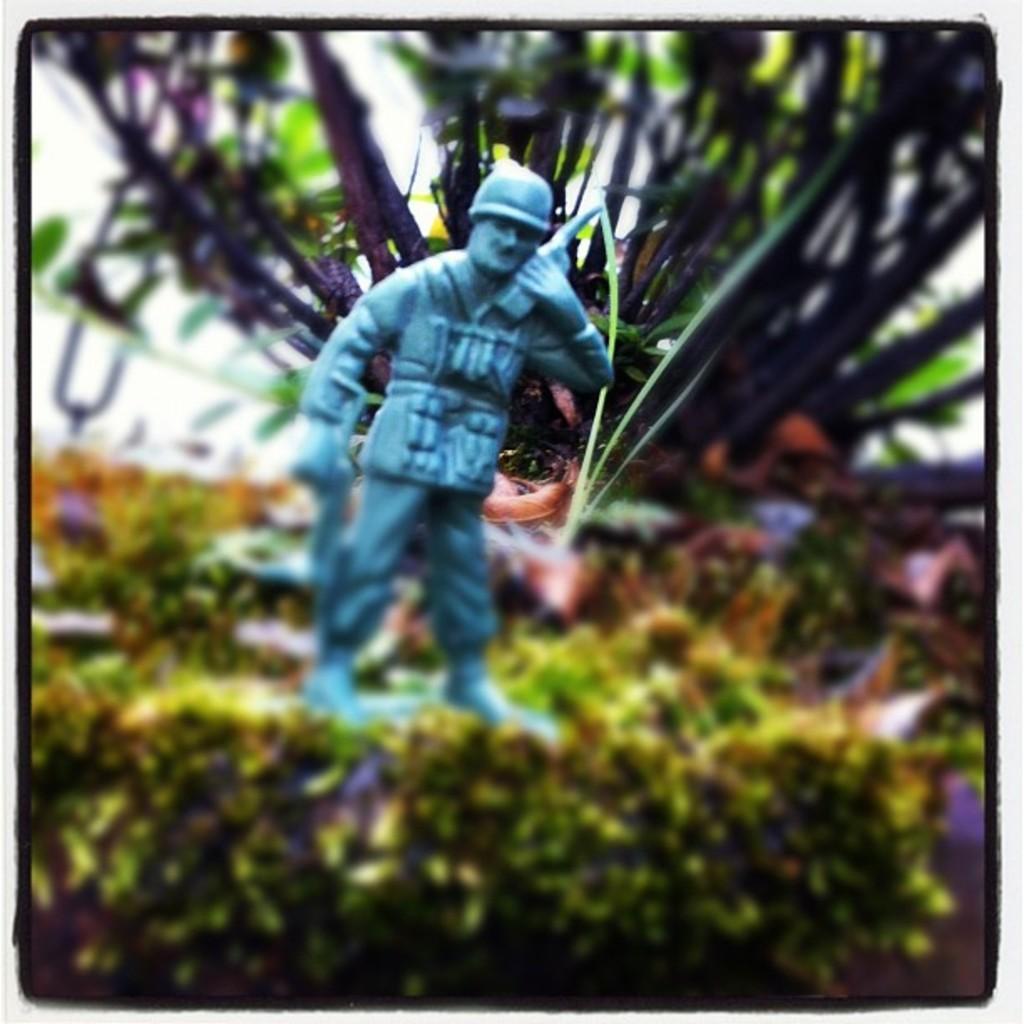How would you summarize this image in a sentence or two? In this image I can see a grey color statue. Back I can see few trees and blurred background. 